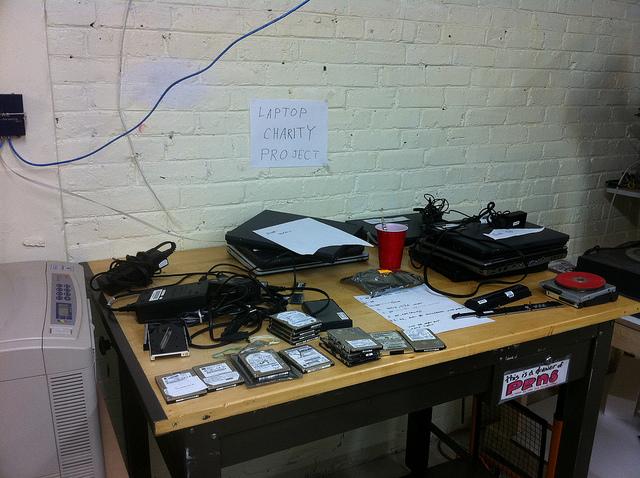Is there a window in the room?
Short answer required. No. What is clear on the wall?
Short answer required. Sign. What room is this?
Answer briefly. Office. What logo is on the cup?
Be succinct. Solo. Is there any drink on the table?
Give a very brief answer. Yes. What kind of pictures are shown?
Quick response, please. None. Is there a red solo cup?
Short answer required. Yes. What is required in order to be able to use this equipment?
Write a very short answer. Computer. 